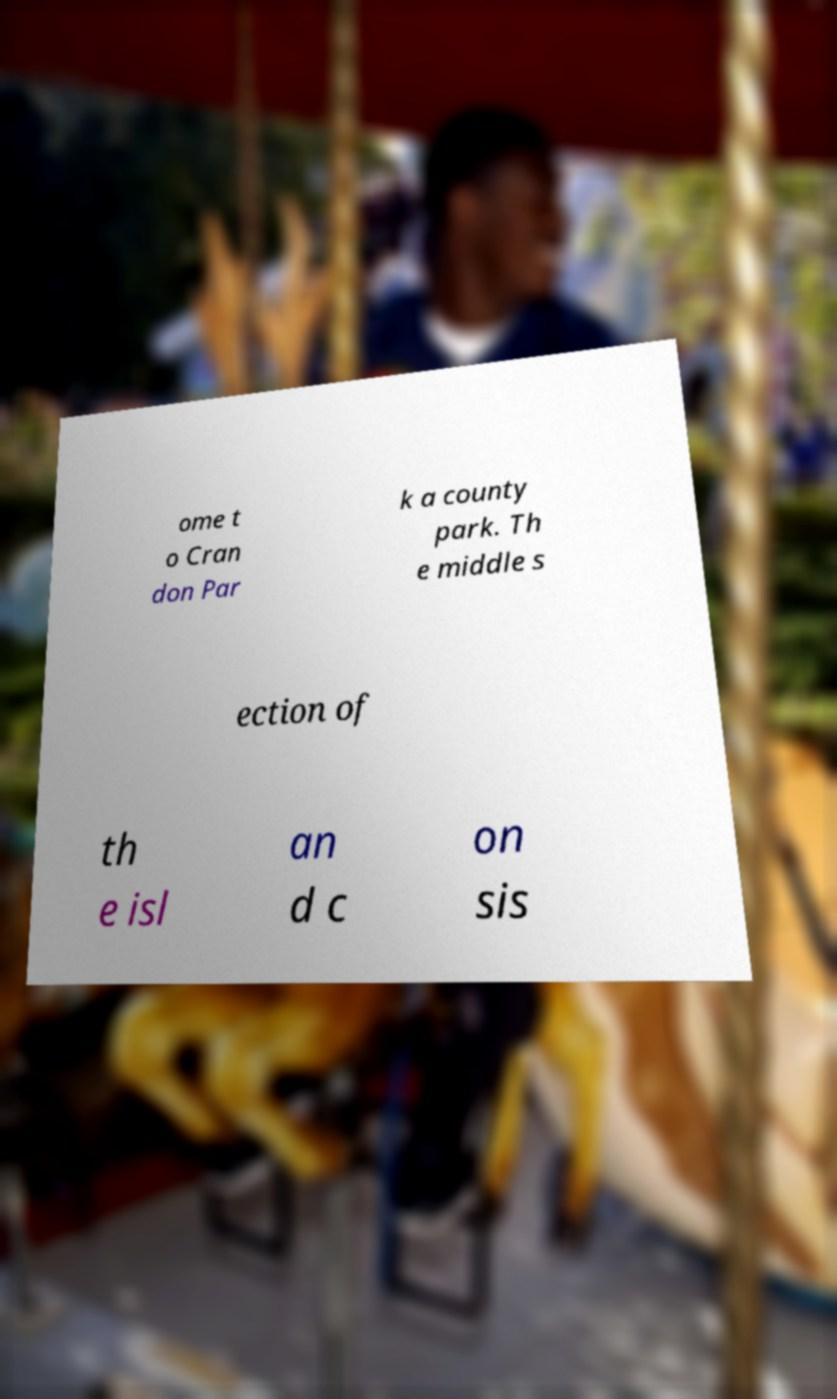Could you assist in decoding the text presented in this image and type it out clearly? ome t o Cran don Par k a county park. Th e middle s ection of th e isl an d c on sis 